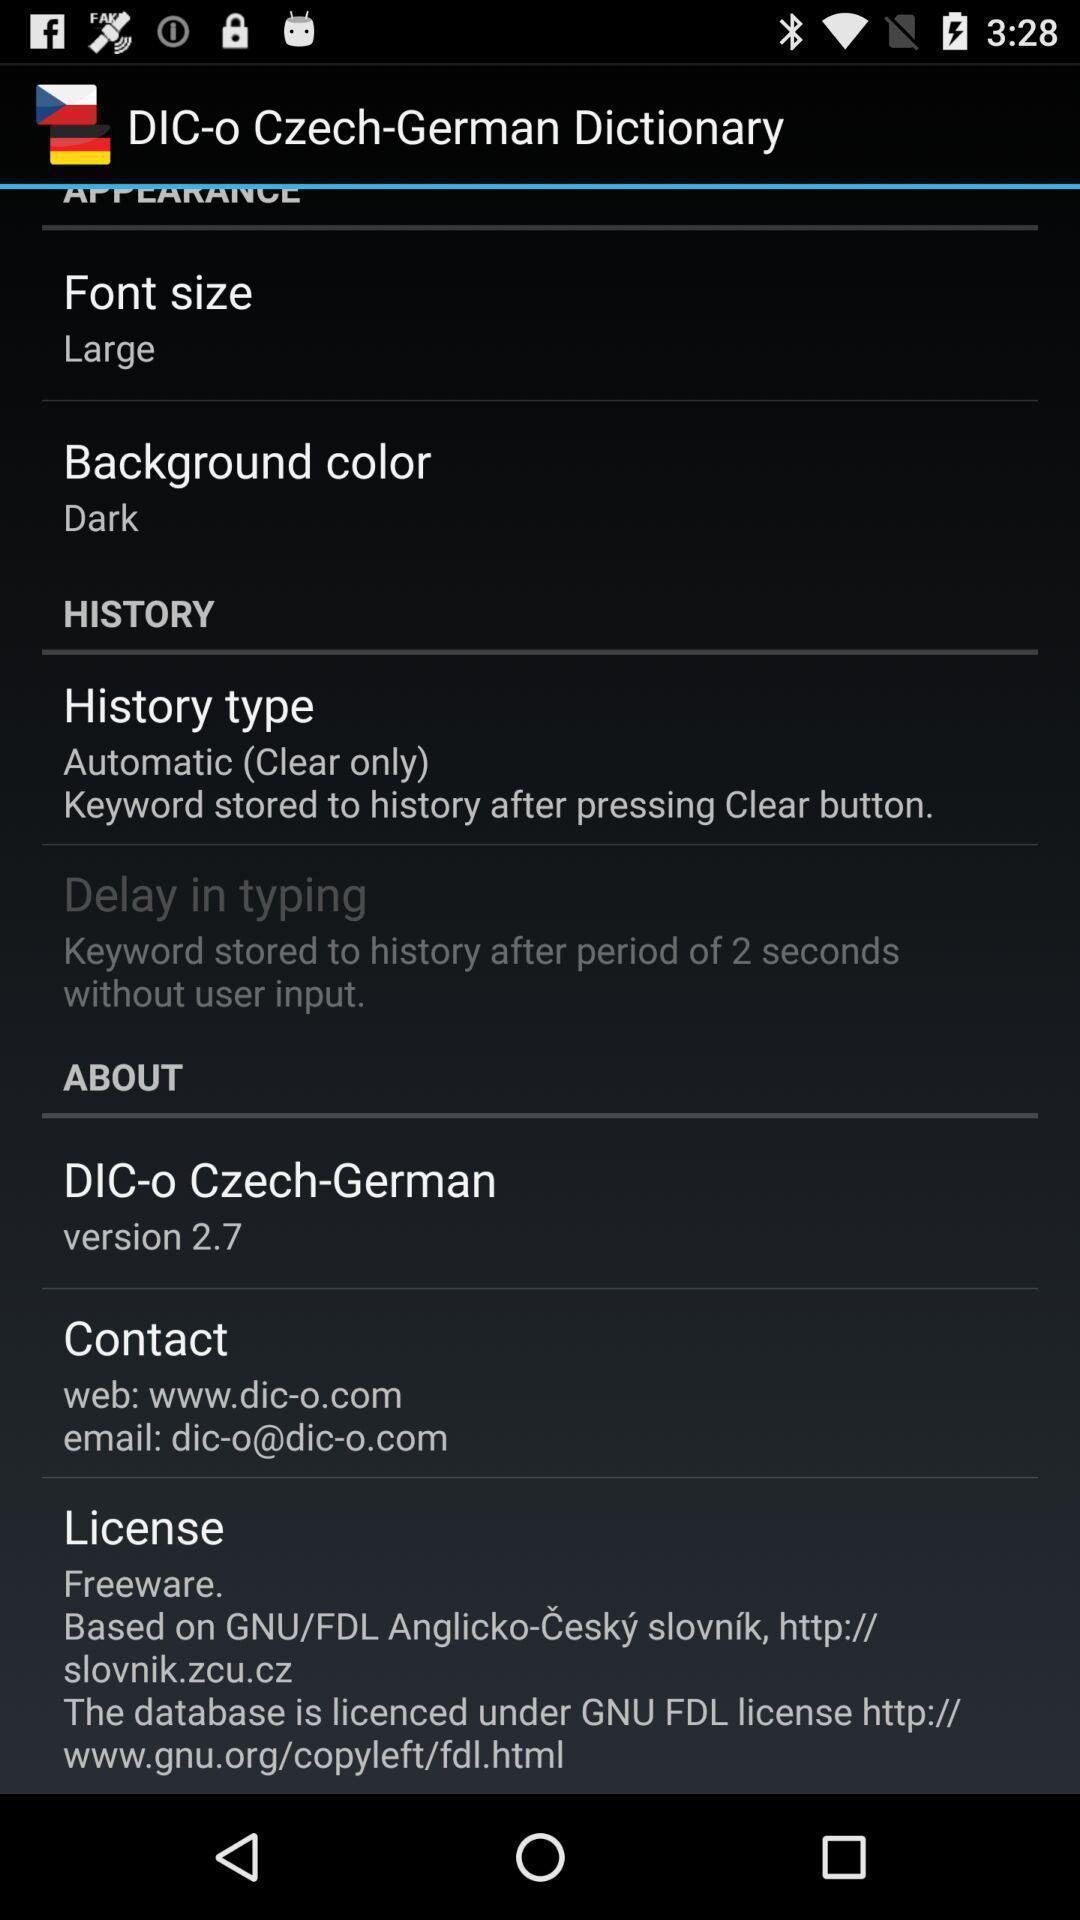What is the overall content of this screenshot? Settings page. 